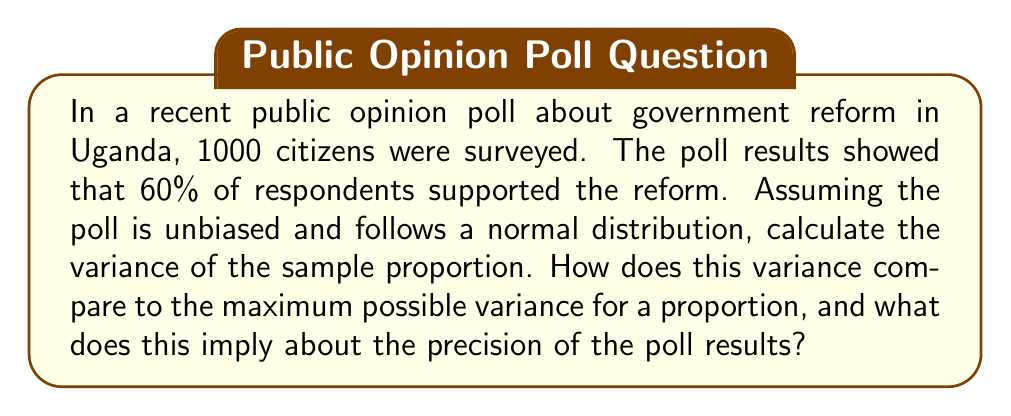Teach me how to tackle this problem. Let's approach this step-by-step:

1) For a binomial distribution (which this poll follows), the variance of a sample proportion is given by:

   $$\text{Var}(\hat{p}) = \frac{p(1-p)}{n}$$

   Where $\hat{p}$ is the sample proportion, $p$ is the true population proportion, and $n$ is the sample size.

2) We don't know the true population proportion, so we use the sample proportion as an estimate:
   $\hat{p} = 0.60$

3) Substituting into the formula:

   $$\text{Var}(\hat{p}) = \frac{0.60(1-0.60)}{1000} = \frac{0.60(0.40)}{1000} = \frac{0.24}{1000} = 0.00024$$

4) The maximum variance for a proportion occurs when $p = 0.5$. Let's calculate this:

   $$\text{Max Var}(\hat{p}) = \frac{0.5(1-0.5)}{1000} = \frac{0.25}{1000} = 0.00025$$

5) Comparing our variance to the maximum:

   $$\frac{0.00024}{0.00025} = 0.96 \text{ or } 96\%$$

This means our variance is 96% of the maximum possible variance.

6) The standard error (SE) is the square root of the variance:

   $$SE = \sqrt{0.00024} \approx 0.0155 \text{ or } 1.55\%$$

This implies that the poll results are quite precise, with a margin of error of about ±3.1% (2 SE) at a 95% confidence level.
Answer: Variance = 0.00024; 96% of max variance; SE ≈ 1.55% 